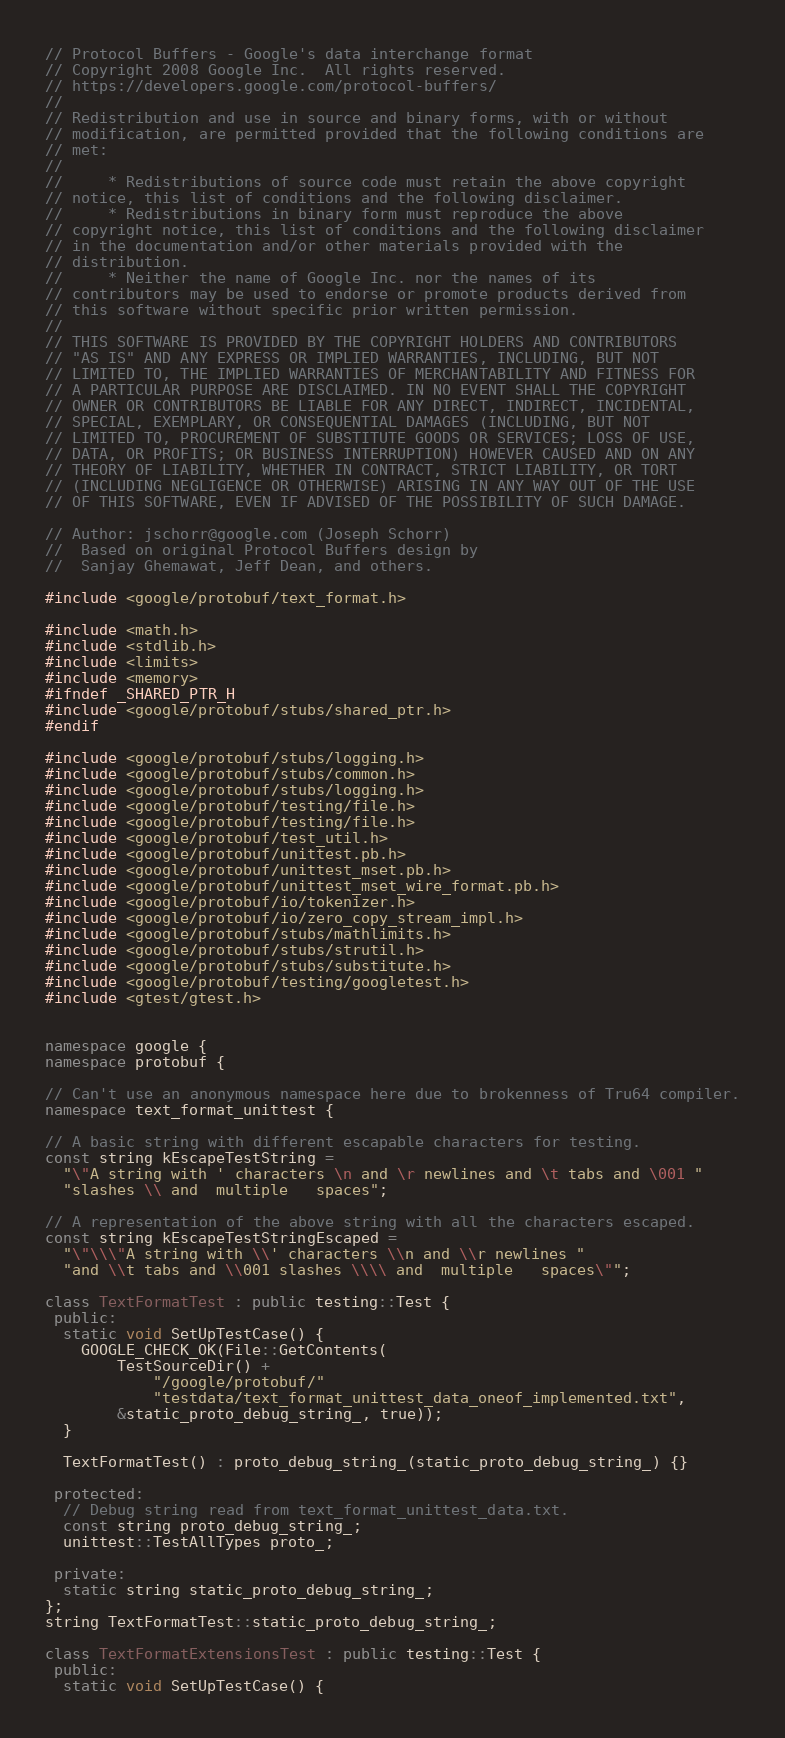<code> <loc_0><loc_0><loc_500><loc_500><_C++_>// Protocol Buffers - Google's data interchange format
// Copyright 2008 Google Inc.  All rights reserved.
// https://developers.google.com/protocol-buffers/
//
// Redistribution and use in source and binary forms, with or without
// modification, are permitted provided that the following conditions are
// met:
//
//     * Redistributions of source code must retain the above copyright
// notice, this list of conditions and the following disclaimer.
//     * Redistributions in binary form must reproduce the above
// copyright notice, this list of conditions and the following disclaimer
// in the documentation and/or other materials provided with the
// distribution.
//     * Neither the name of Google Inc. nor the names of its
// contributors may be used to endorse or promote products derived from
// this software without specific prior written permission.
//
// THIS SOFTWARE IS PROVIDED BY THE COPYRIGHT HOLDERS AND CONTRIBUTORS
// "AS IS" AND ANY EXPRESS OR IMPLIED WARRANTIES, INCLUDING, BUT NOT
// LIMITED TO, THE IMPLIED WARRANTIES OF MERCHANTABILITY AND FITNESS FOR
// A PARTICULAR PURPOSE ARE DISCLAIMED. IN NO EVENT SHALL THE COPYRIGHT
// OWNER OR CONTRIBUTORS BE LIABLE FOR ANY DIRECT, INDIRECT, INCIDENTAL,
// SPECIAL, EXEMPLARY, OR CONSEQUENTIAL DAMAGES (INCLUDING, BUT NOT
// LIMITED TO, PROCUREMENT OF SUBSTITUTE GOODS OR SERVICES; LOSS OF USE,
// DATA, OR PROFITS; OR BUSINESS INTERRUPTION) HOWEVER CAUSED AND ON ANY
// THEORY OF LIABILITY, WHETHER IN CONTRACT, STRICT LIABILITY, OR TORT
// (INCLUDING NEGLIGENCE OR OTHERWISE) ARISING IN ANY WAY OUT OF THE USE
// OF THIS SOFTWARE, EVEN IF ADVISED OF THE POSSIBILITY OF SUCH DAMAGE.

// Author: jschorr@google.com (Joseph Schorr)
//  Based on original Protocol Buffers design by
//  Sanjay Ghemawat, Jeff Dean, and others.

#include <google/protobuf/text_format.h>

#include <math.h>
#include <stdlib.h>
#include <limits>
#include <memory>
#ifndef _SHARED_PTR_H
#include <google/protobuf/stubs/shared_ptr.h>
#endif

#include <google/protobuf/stubs/logging.h>
#include <google/protobuf/stubs/common.h>
#include <google/protobuf/stubs/logging.h>
#include <google/protobuf/testing/file.h>
#include <google/protobuf/testing/file.h>
#include <google/protobuf/test_util.h>
#include <google/protobuf/unittest.pb.h>
#include <google/protobuf/unittest_mset.pb.h>
#include <google/protobuf/unittest_mset_wire_format.pb.h>
#include <google/protobuf/io/tokenizer.h>
#include <google/protobuf/io/zero_copy_stream_impl.h>
#include <google/protobuf/stubs/mathlimits.h>
#include <google/protobuf/stubs/strutil.h>
#include <google/protobuf/stubs/substitute.h>
#include <google/protobuf/testing/googletest.h>
#include <gtest/gtest.h>


namespace google {
namespace protobuf {

// Can't use an anonymous namespace here due to brokenness of Tru64 compiler.
namespace text_format_unittest {

// A basic string with different escapable characters for testing.
const string kEscapeTestString =
  "\"A string with ' characters \n and \r newlines and \t tabs and \001 "
  "slashes \\ and  multiple   spaces";

// A representation of the above string with all the characters escaped.
const string kEscapeTestStringEscaped =
  "\"\\\"A string with \\' characters \\n and \\r newlines "
  "and \\t tabs and \\001 slashes \\\\ and  multiple   spaces\"";

class TextFormatTest : public testing::Test {
 public:
  static void SetUpTestCase() {
    GOOGLE_CHECK_OK(File::GetContents(
        TestSourceDir() +
            "/google/protobuf/"
            "testdata/text_format_unittest_data_oneof_implemented.txt",
        &static_proto_debug_string_, true));
  }

  TextFormatTest() : proto_debug_string_(static_proto_debug_string_) {}

 protected:
  // Debug string read from text_format_unittest_data.txt.
  const string proto_debug_string_;
  unittest::TestAllTypes proto_;

 private:
  static string static_proto_debug_string_;
};
string TextFormatTest::static_proto_debug_string_;

class TextFormatExtensionsTest : public testing::Test {
 public:
  static void SetUpTestCase() {</code> 